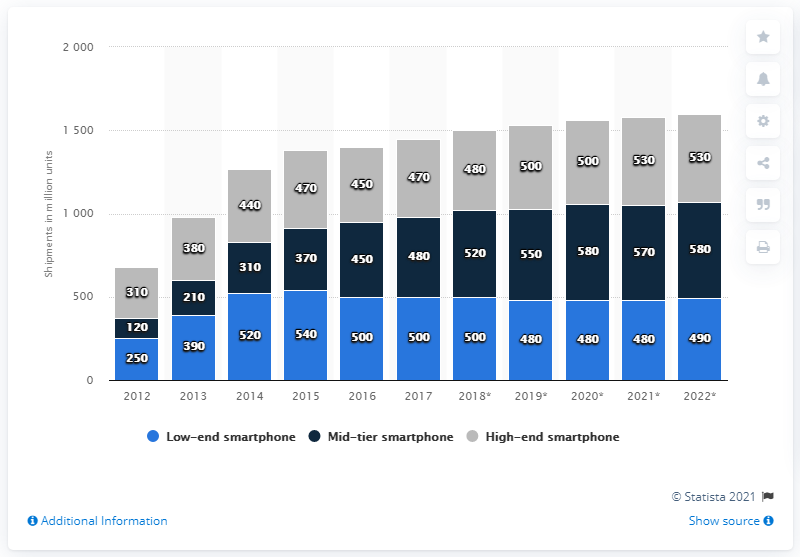Point out several critical features in this image. In 2014, a total of 520 low-end smartphones were shipped worldwide. The difference between the highest amount of low-end smartphones shipped over the years and the lowest amount of high-end smartphones shipped is 230. 